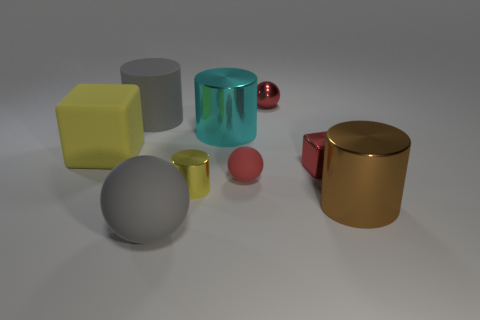What is the material of the big gray thing that is behind the block on the left side of the metal object behind the gray cylinder?
Provide a succinct answer. Rubber. What number of things are either large spheres or small red things that are in front of the small shiny ball?
Provide a short and direct response. 3. Does the ball in front of the big brown shiny cylinder have the same color as the tiny matte object?
Ensure brevity in your answer.  No. Are there more red blocks that are behind the metallic sphere than red shiny balls on the right side of the red metal cube?
Make the answer very short. No. Is there anything else of the same color as the large matte ball?
Your response must be concise. Yes. What number of things are either tiny rubber spheres or big yellow cubes?
Give a very brief answer. 2. Do the cylinder right of the red matte thing and the gray matte cylinder have the same size?
Ensure brevity in your answer.  Yes. What number of other objects are the same size as the red metallic ball?
Give a very brief answer. 3. Is there a tiny yellow metal object?
Keep it short and to the point. Yes. There is a gray object in front of the block that is to the right of the big gray ball; what size is it?
Give a very brief answer. Large. 